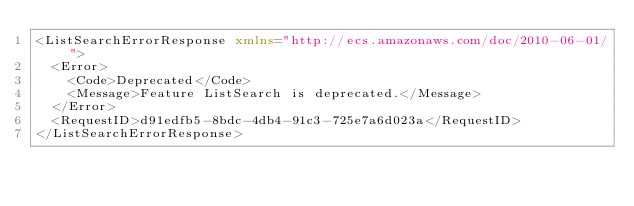<code> <loc_0><loc_0><loc_500><loc_500><_XML_><ListSearchErrorResponse xmlns="http://ecs.amazonaws.com/doc/2010-06-01/">
  <Error>
    <Code>Deprecated</Code>
    <Message>Feature ListSearch is deprecated.</Message>
  </Error>
  <RequestID>d91edfb5-8bdc-4db4-91c3-725e7a6d023a</RequestID>
</ListSearchErrorResponse>
</code> 